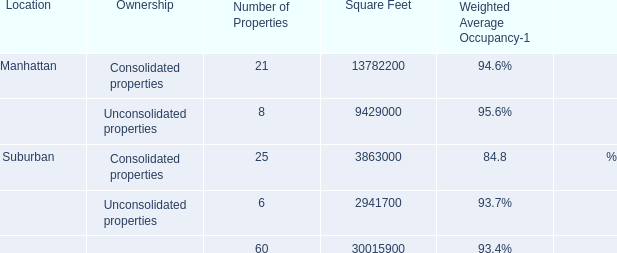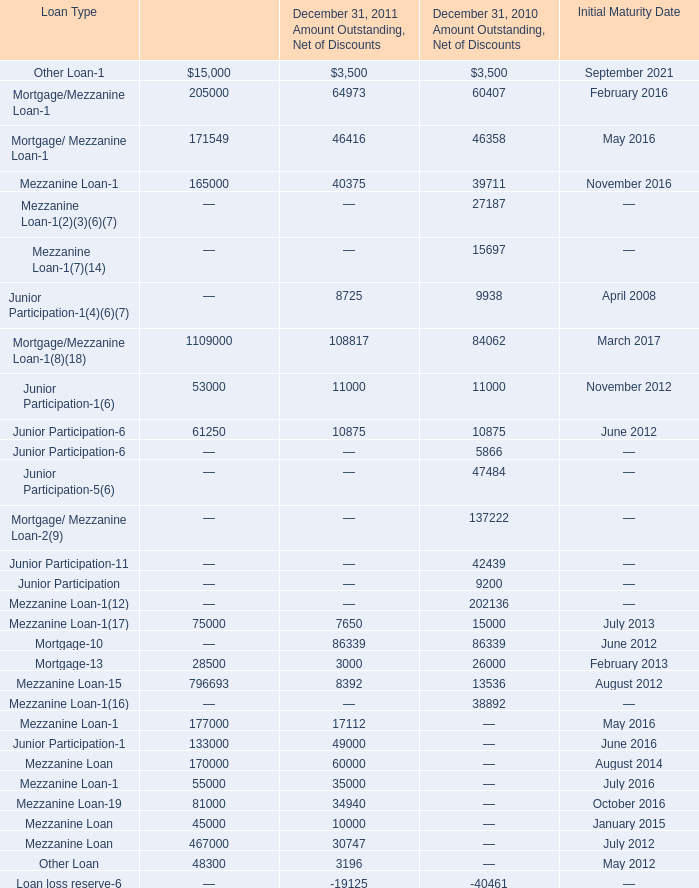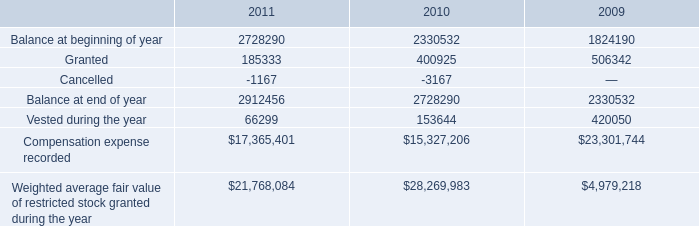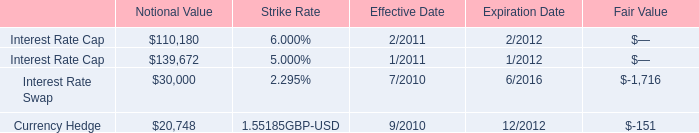what amount did the compensation committee put into the maximum performance pool between jan 1 2006 and dec 31 2007? 
Computations: (22825000 + 49250000)
Answer: 72075000.0. 